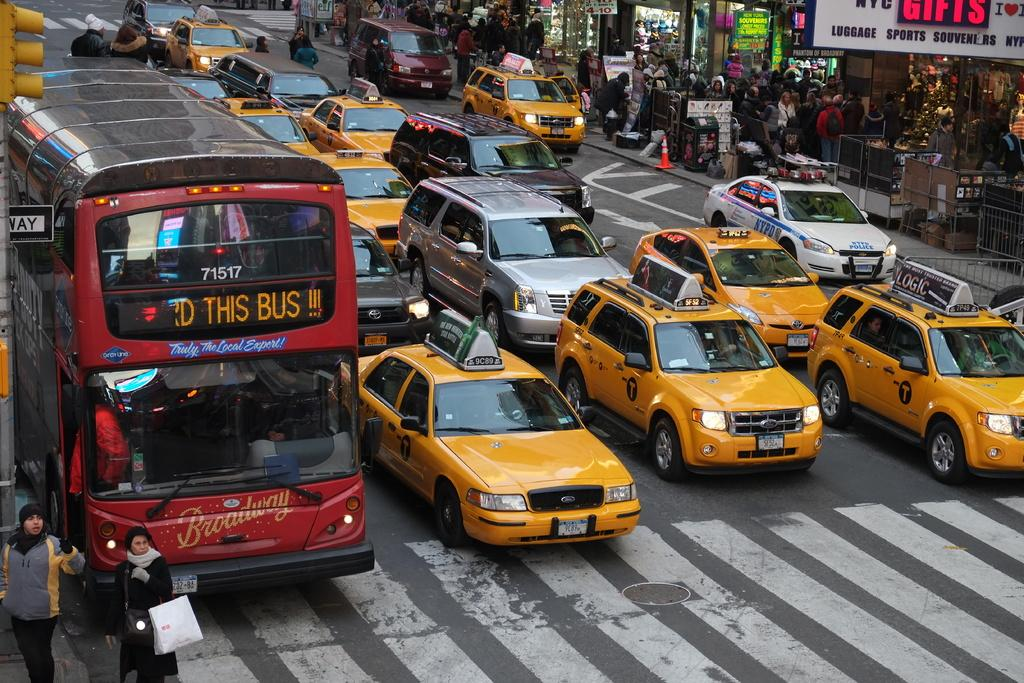<image>
Present a compact description of the photo's key features. a bus with the words this bus on the top 